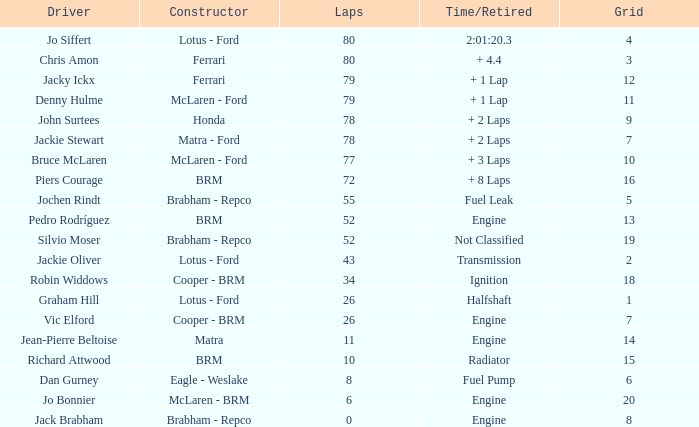When the driver richard attwood has a maker of brm, what is the total of laps? 10.0. 